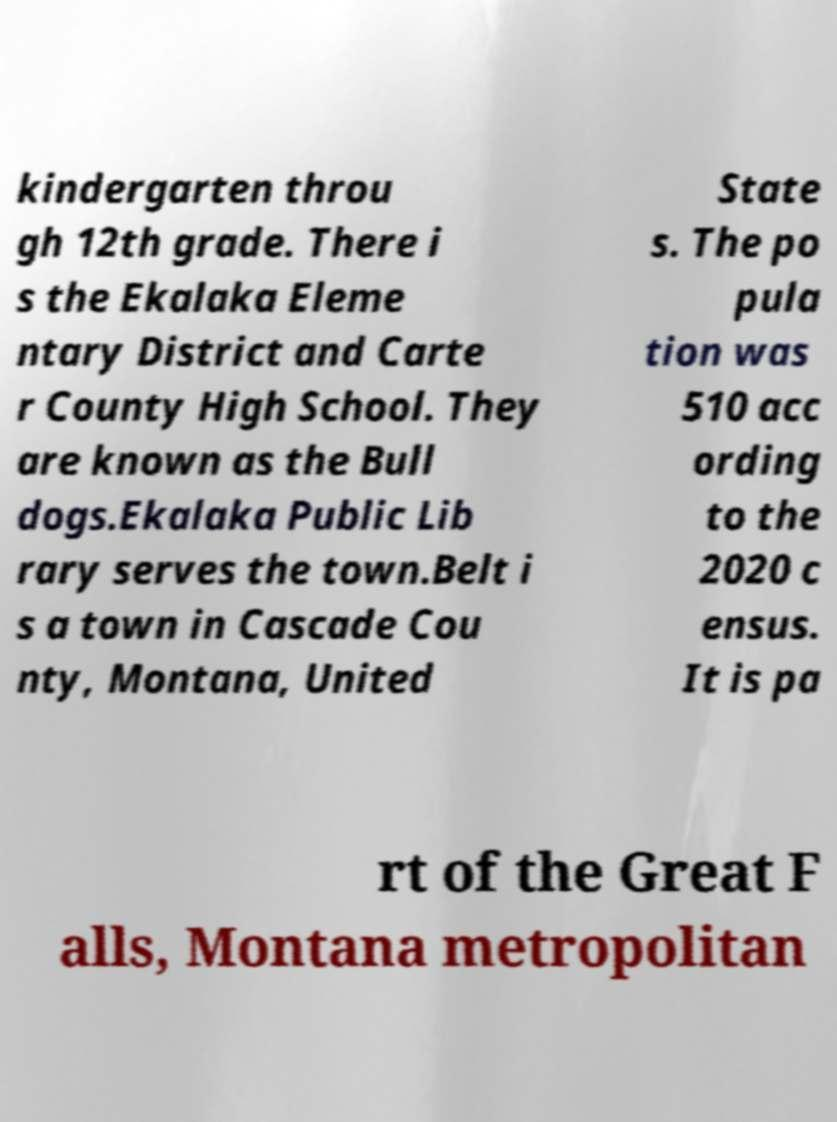Can you accurately transcribe the text from the provided image for me? kindergarten throu gh 12th grade. There i s the Ekalaka Eleme ntary District and Carte r County High School. They are known as the Bull dogs.Ekalaka Public Lib rary serves the town.Belt i s a town in Cascade Cou nty, Montana, United State s. The po pula tion was 510 acc ording to the 2020 c ensus. It is pa rt of the Great F alls, Montana metropolitan 